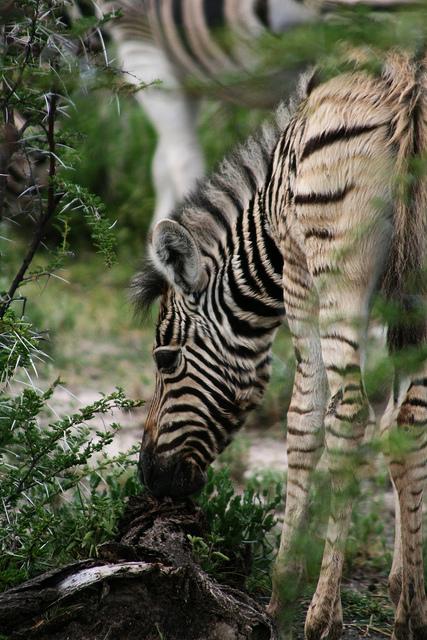Are any of the animals eating?
Short answer required. Yes. Is this zebra angry?
Answer briefly. No. Is this a daytime photo?
Be succinct. Yes. Is the zebra eating?
Short answer required. Yes. What is the animal smelling?
Write a very short answer. Grass. 